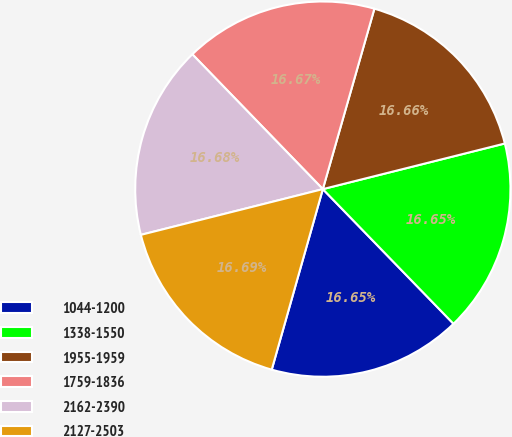Convert chart to OTSL. <chart><loc_0><loc_0><loc_500><loc_500><pie_chart><fcel>1044-1200<fcel>1338-1550<fcel>1955-1959<fcel>1759-1836<fcel>2162-2390<fcel>2127-2503<nl><fcel>16.65%<fcel>16.65%<fcel>16.66%<fcel>16.67%<fcel>16.68%<fcel>16.69%<nl></chart> 